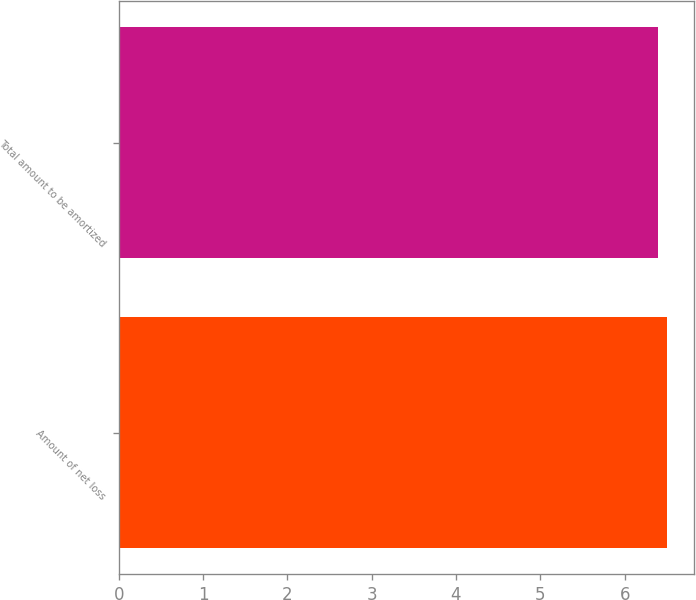Convert chart to OTSL. <chart><loc_0><loc_0><loc_500><loc_500><bar_chart><fcel>Amount of net loss<fcel>Total amount to be amortized<nl><fcel>6.5<fcel>6.4<nl></chart> 